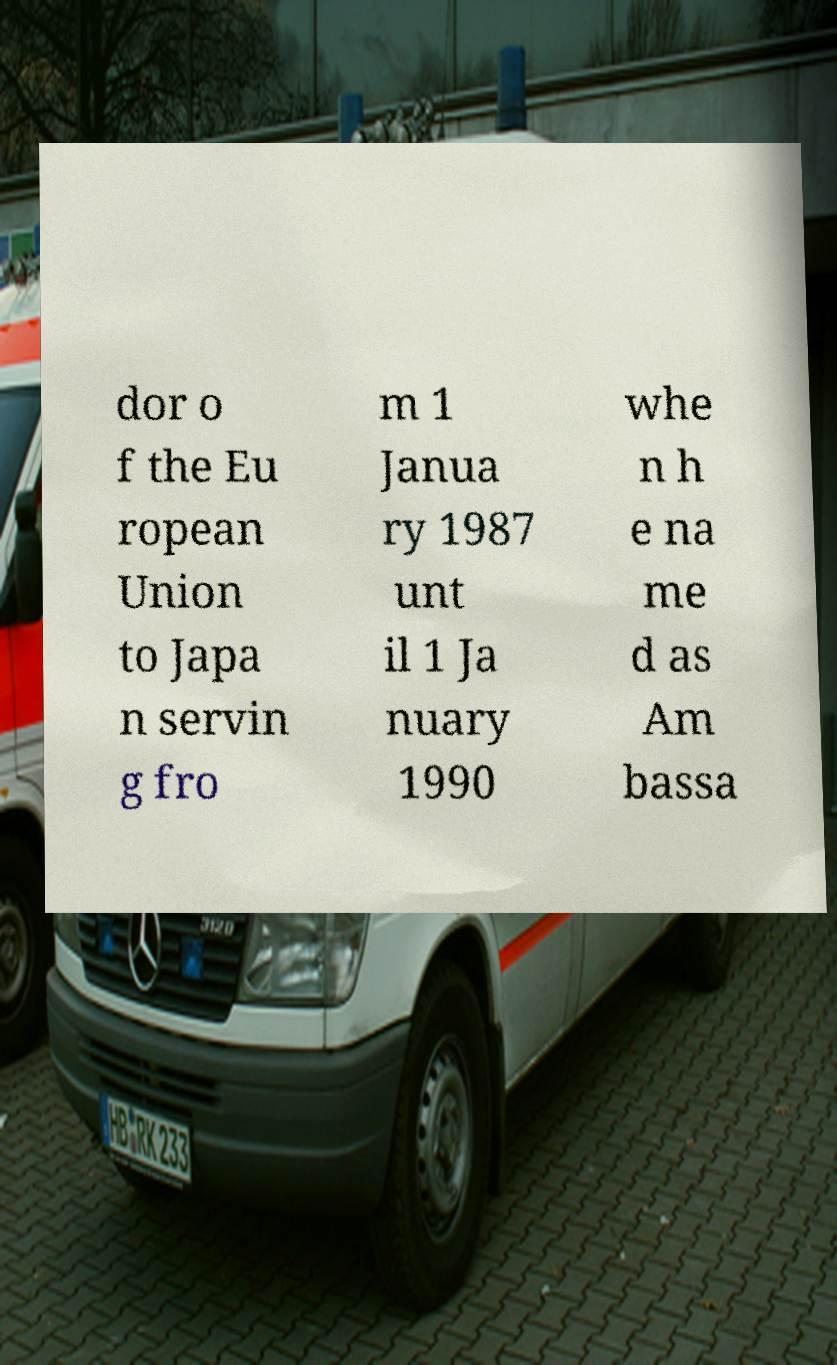I need the written content from this picture converted into text. Can you do that? dor o f the Eu ropean Union to Japa n servin g fro m 1 Janua ry 1987 unt il 1 Ja nuary 1990 whe n h e na me d as Am bassa 